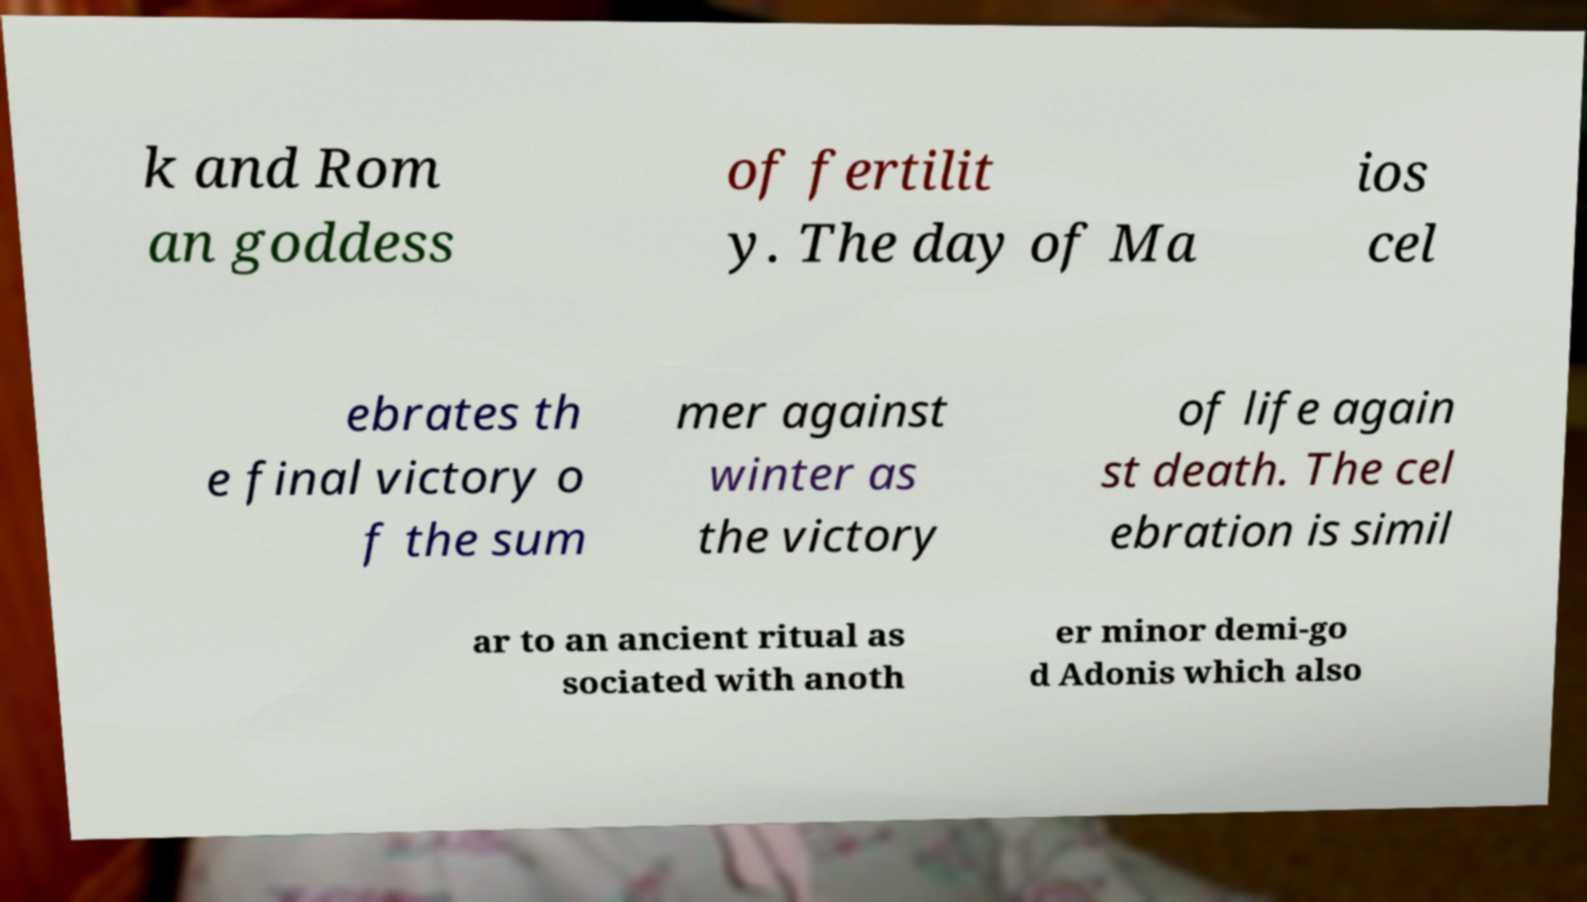Could you extract and type out the text from this image? k and Rom an goddess of fertilit y. The day of Ma ios cel ebrates th e final victory o f the sum mer against winter as the victory of life again st death. The cel ebration is simil ar to an ancient ritual as sociated with anoth er minor demi-go d Adonis which also 